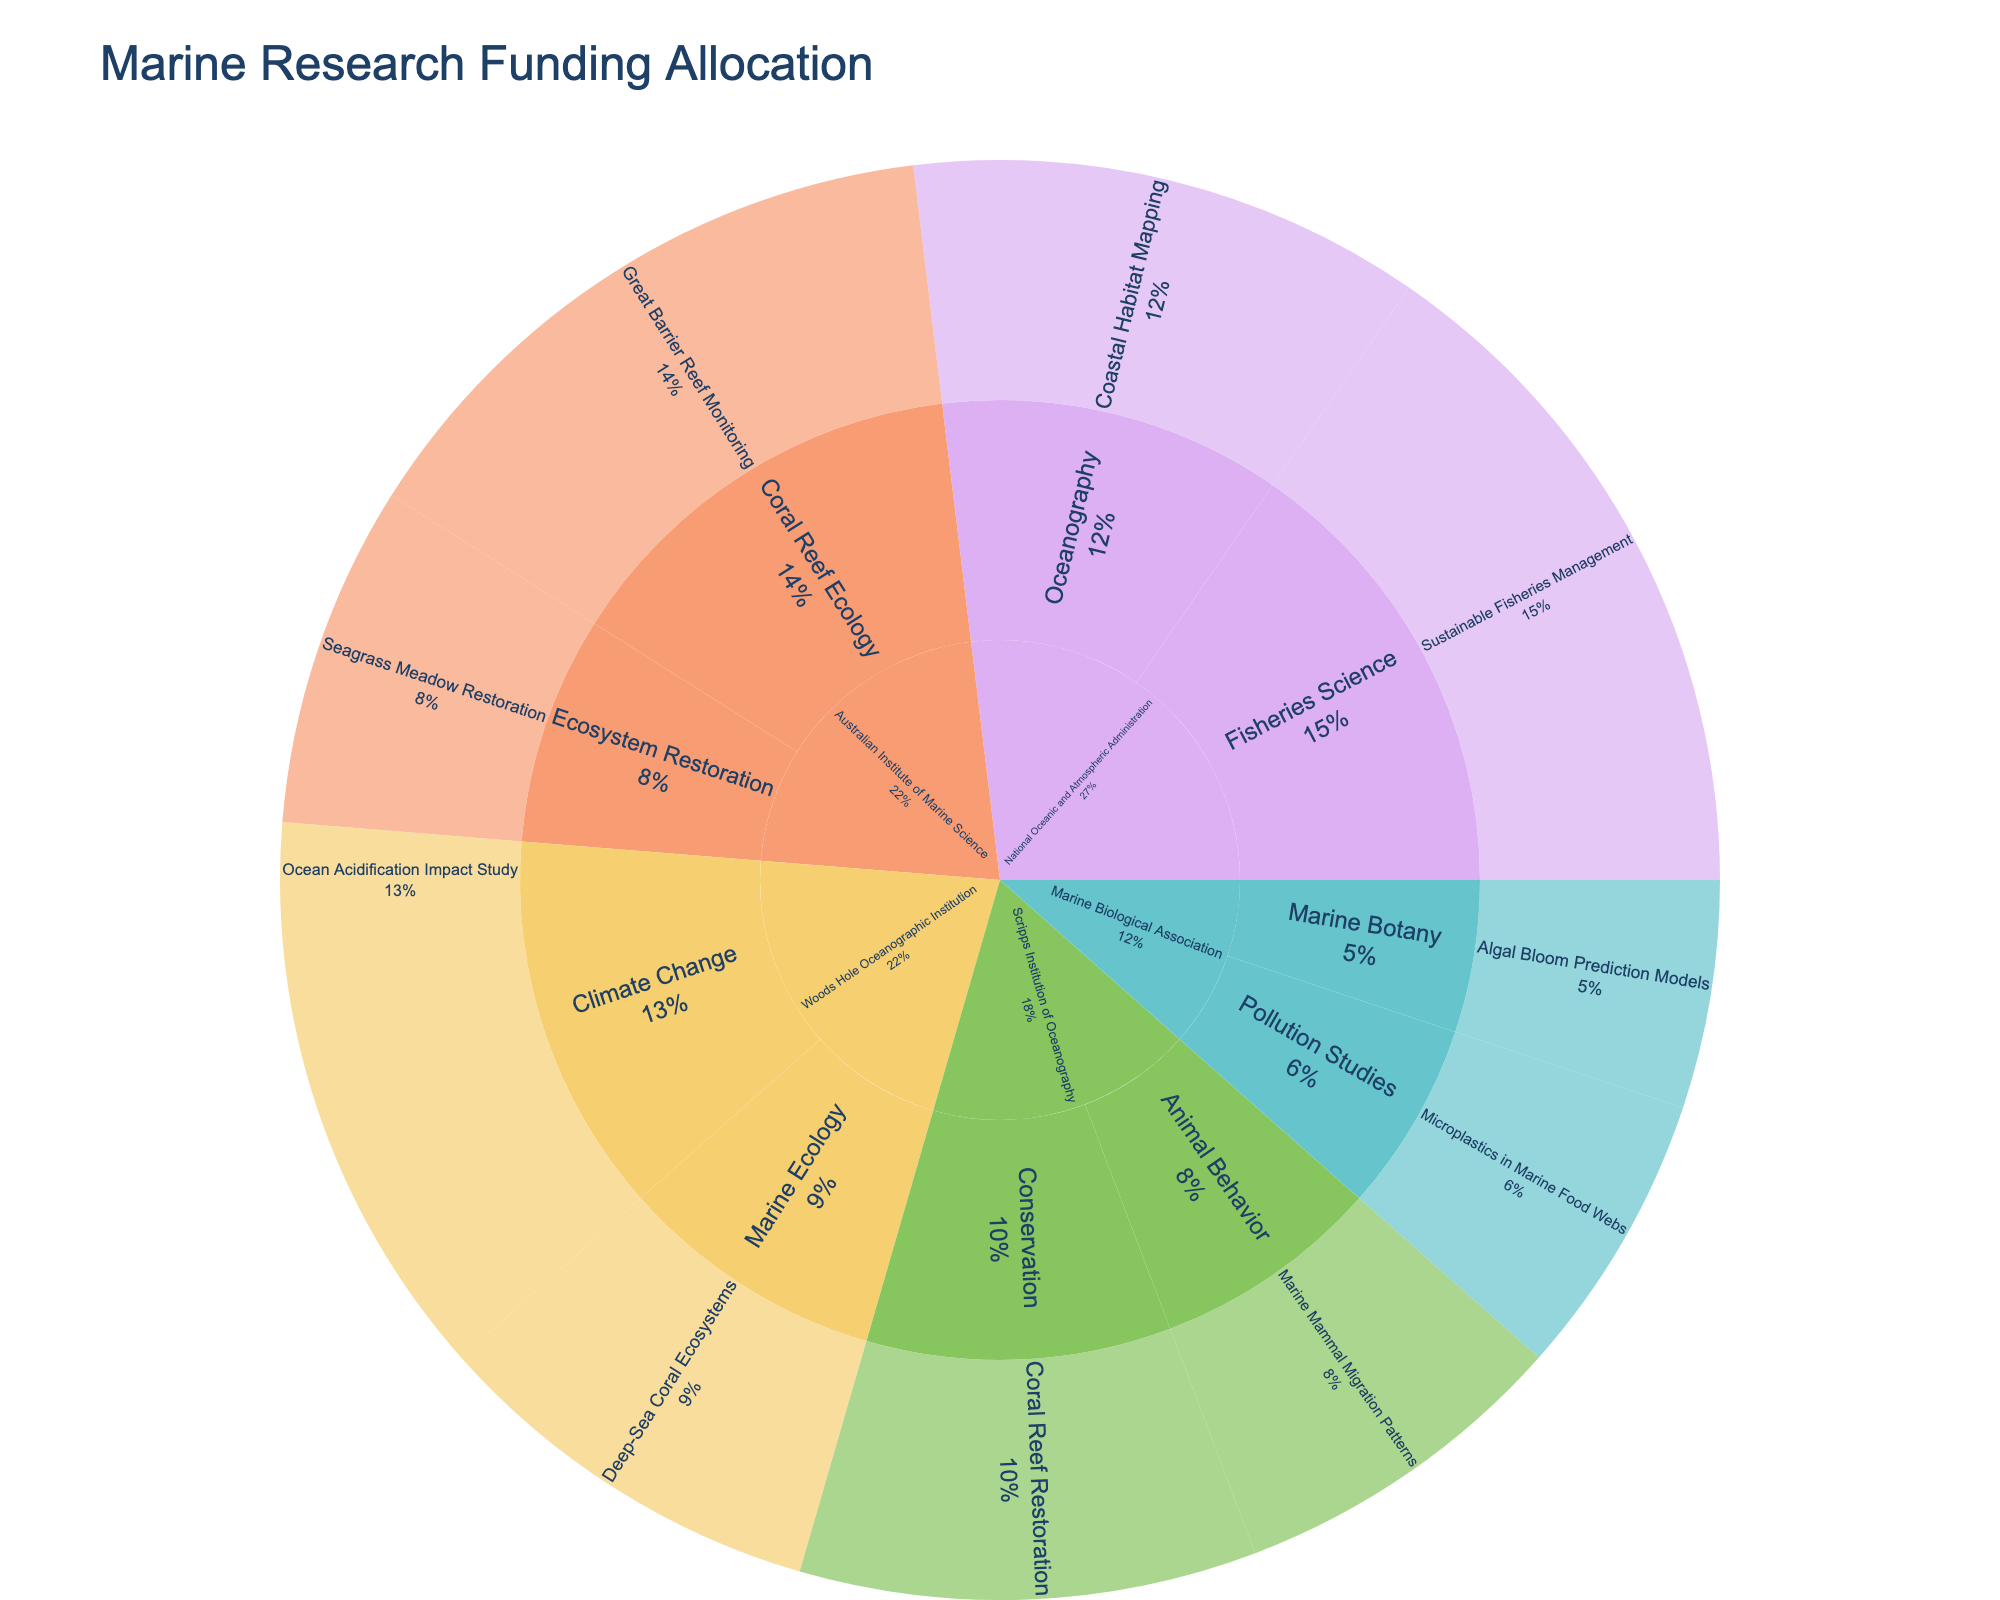Which institution received the highest amount of funding? The institution with the highest funding can be identified by looking at the outermost ring and comparing the sizes of the segments. From the figure, the National Oceanic and Atmospheric Administration segment is the largest.
Answer: National Oceanic and Atmospheric Administration What is the total funding allocated to the Woods Hole Oceanographic Institution? Add up the funding amounts for all projects under Woods Hole Oceanographic Institution. These are Ocean Acidification Impact Study ($5,000,000) and Deep-Sea Coral Ecosystems ($3,500,000). The total is $5,000,000 + $3,500,000 = $8,500,000.
Answer: $8,500,000 Which research area received the highest funding within the Australian Institute of Marine Science? Examine the funding amounts for each research area under the Australian Institute of Marine Science. Great Barrier Reef Monitoring received $5,500,000, while Seagrass Meadow Restoration received $3,000,000. The higher amount is $5,500,000 for Great Barrier Reef Monitoring.
Answer: Great Barrier Reef Monitoring How does the total funding for Conservation projects compare to Ecosystem Restoration projects? Conservation projects (Coral Reef Restoration) received $4,000,000. Ecosystem Restoration projects (Seagrass Meadow Restoration) received $3,000,000. Conservation has more funding than Ecosystem Restoration by $1,000,000.
Answer: Conservation projects have $1,000,000 more funding What percentage of funding does the Marine Biological Association contribute to Pollution Studies? The Marine Biological Association allocates $2,500,000 to Pollution Studies. To find the percentage, calculate the figure's total funding and compute the ratio. The total funding is $41,500,000 (sum of all segments). So, the percentage is ($2,500,000 / $41,500,000) * 100 ≈ 6.02%.
Answer: Approximately 6.02% Which project under the National Oceanic and Atmospheric Administration received the highest funding? Compare the funding amounts of projects under the National Oceanic and Atmospheric Administration. Sustainable Fisheries Management received $6,000,000, and Coastal Habitat Mapping received $4,500,000. The higher amount is $6,000,000 for Sustainable Fisheries Management.
Answer: Sustainable Fisheries Management How does the funding for Animal Behavior compare to Marine Botany in the Scripps Institution of Oceanography? Under the Scripps Institution of Oceanography, Animal Behavior (Marine Mammal Migration Patterns) received $3,000,000, while Marine Botany (Algal Bloom Prediction Models) is not listed under Scripps but under the Marine Biological Association. For Scripps, Animal Behavior is $3,000,000 whereas, for Marine Biology, it is $2,000,000 under a different institution. Animal Behavior has a higher amount.
Answer: Animal Behavior has more funding What is the average funding amount per project across all institutions? The average can be calculated by summing all the funding amounts and dividing by the number of projects. The total funding is $41,500,000, and there are 10 projects. So, the average is $41,500,000 / 10 = $4,150,000.
Answer: $4,150,000 Which institution has the largest diversity in research areas? Count the distinct research areas under each institution. Woods Hole Oceanographic Institution and National Oceanic and Atmospheric Administration each have two different research areas, while others have fewer.
Answer: Woods Hole Oceanographic Institution and National Oceanic and Atmospheric Administration What proportion of the total funding is allocated to Marine Mammal Migration Patterns? The funding for Marine Mammal Migration Patterns is $3,000,000. The total funding is $41,500,000. The proportion is ($3,000,000 / $41,500,000) ≈ 0.0723 or 7.23%.
Answer: Approximately 7.23% 